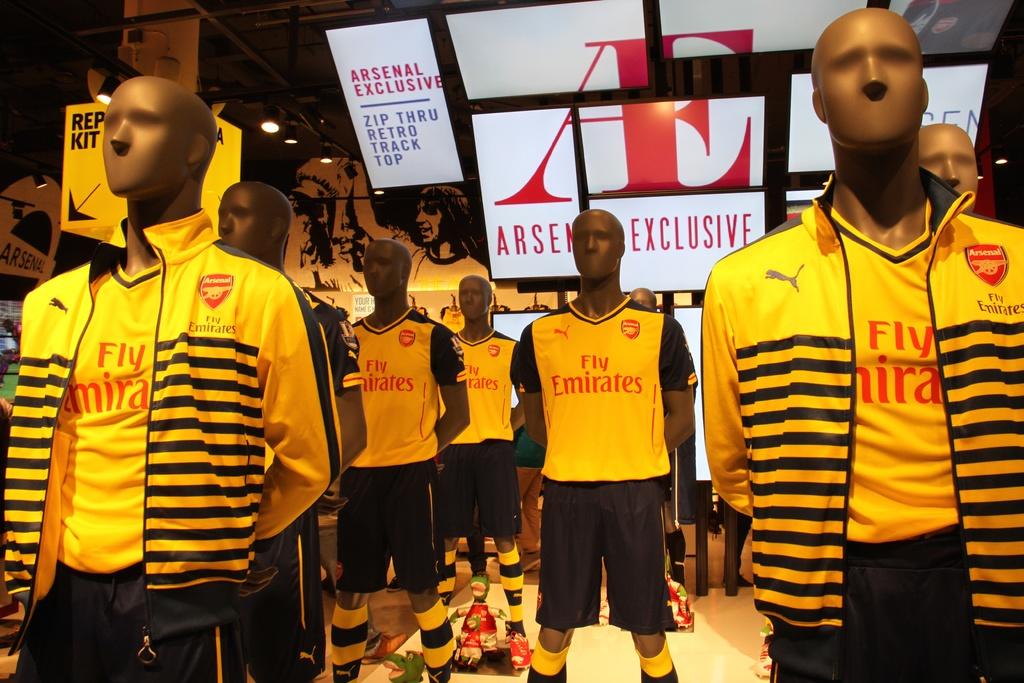What airline is advertised to fly with on their shirts?
Give a very brief answer. Emirates. What team are they playing for?
Your answer should be very brief. Arsenal. 